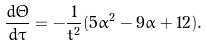Convert formula to latex. <formula><loc_0><loc_0><loc_500><loc_500>\frac { d \Theta } { d \tau } = - \frac { 1 } { t ^ { 2 } } ( 5 \alpha ^ { 2 } - 9 \alpha + 1 2 ) .</formula> 